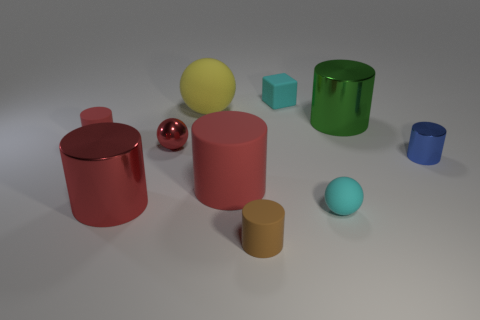What is the texture of the objects like, and how can you tell? The objects seem to have a smooth texture with a glossy finish, as evidenced by the light reflections and highlights on their surfaces. The metallic cylinders, in particular, have a reflective sheen that suggests they are polished. 